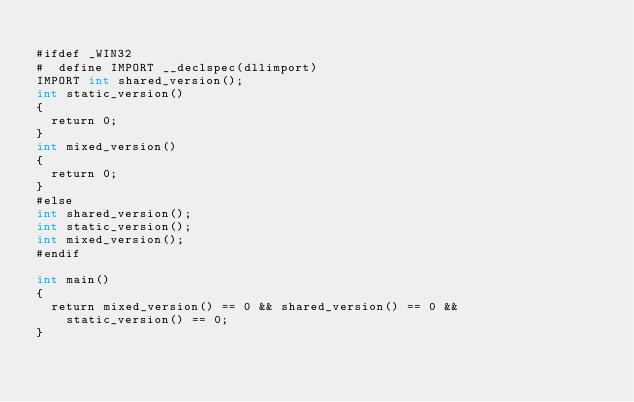Convert code to text. <code><loc_0><loc_0><loc_500><loc_500><_Cuda_>
#ifdef _WIN32
#  define IMPORT __declspec(dllimport)
IMPORT int shared_version();
int static_version()
{
  return 0;
}
int mixed_version()
{
  return 0;
}
#else
int shared_version();
int static_version();
int mixed_version();
#endif

int main()
{
  return mixed_version() == 0 && shared_version() == 0 &&
    static_version() == 0;
}
</code> 